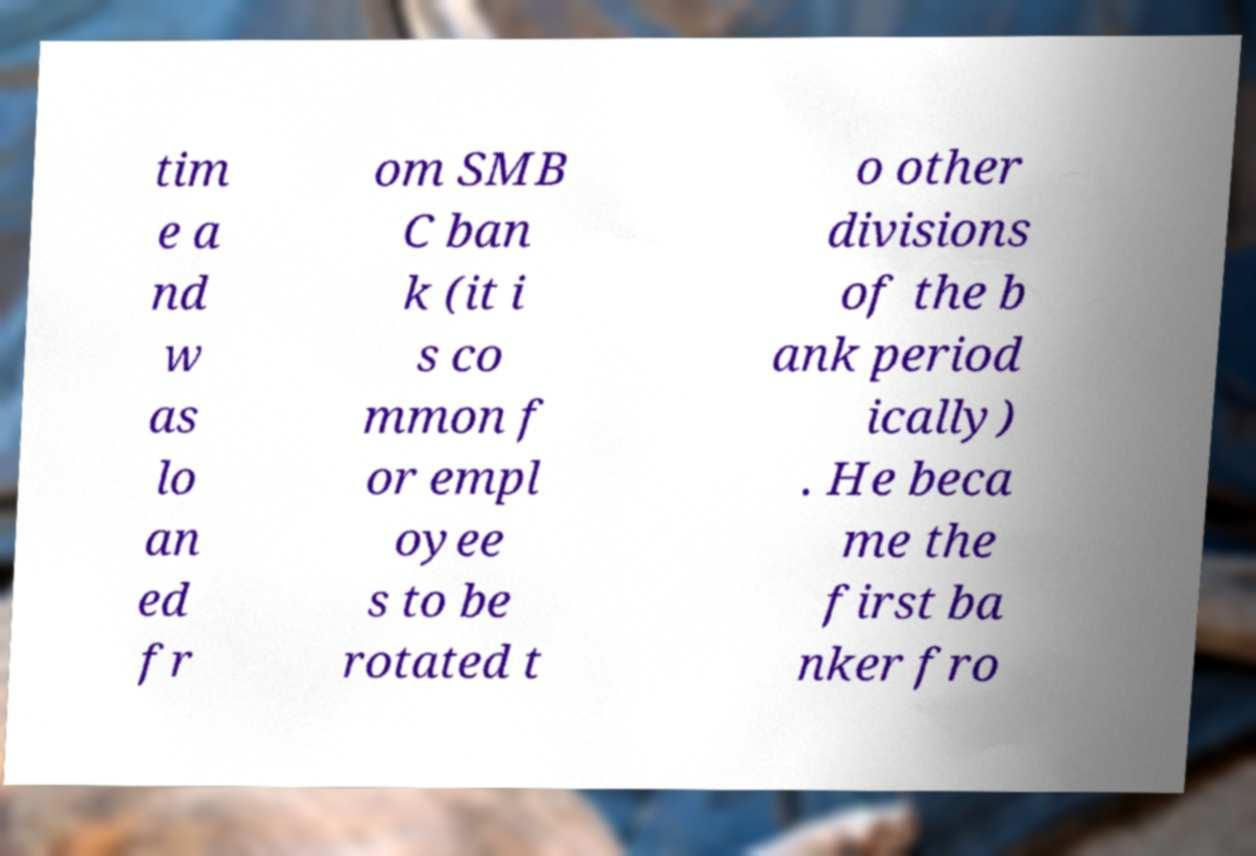I need the written content from this picture converted into text. Can you do that? tim e a nd w as lo an ed fr om SMB C ban k (it i s co mmon f or empl oyee s to be rotated t o other divisions of the b ank period ically) . He beca me the first ba nker fro 